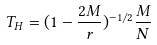Convert formula to latex. <formula><loc_0><loc_0><loc_500><loc_500>T _ { H } = ( 1 - \frac { 2 M } { r } ) ^ { - 1 / 2 } \frac { M } { N }</formula> 